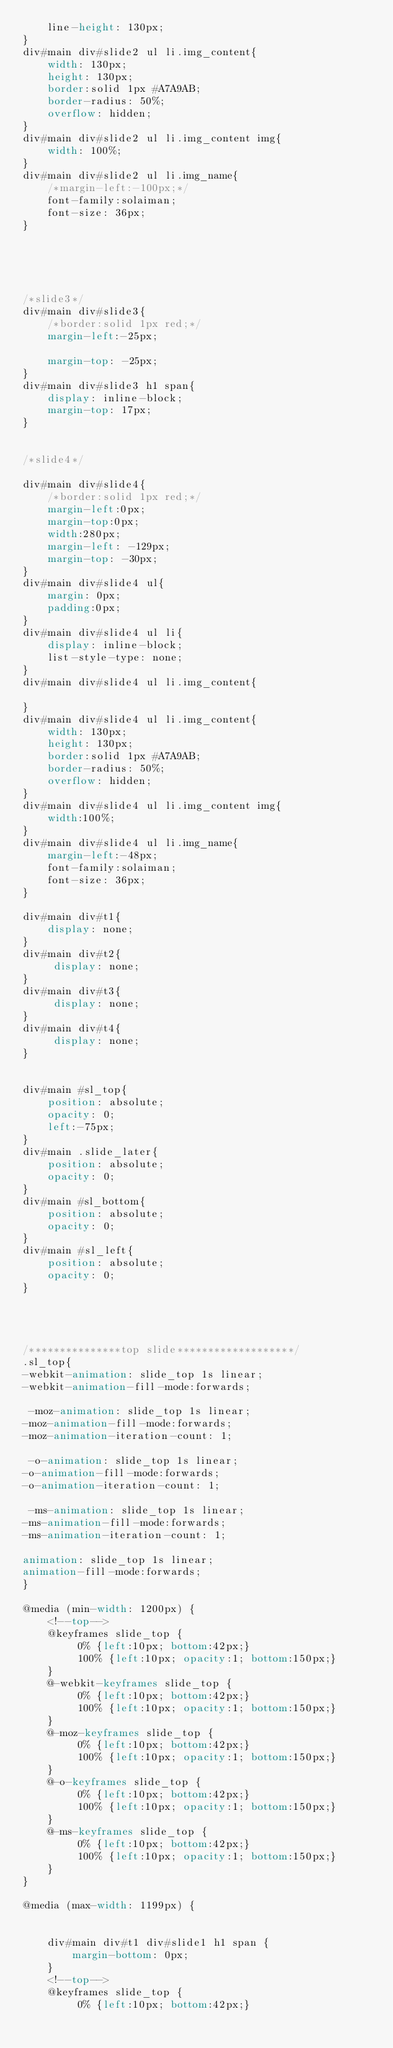Convert code to text. <code><loc_0><loc_0><loc_500><loc_500><_CSS_>    line-height: 130px;
}
div#main div#slide2 ul li.img_content{
    width: 130px;
    height: 130px;
    border:solid 1px #A7A9AB;
    border-radius: 50%;
    overflow: hidden;
}
div#main div#slide2 ul li.img_content img{
    width: 100%;
}
div#main div#slide2 ul li.img_name{
    /*margin-left:-100px;*/
    font-family:solaiman;
    font-size: 36px;
}





/*slide3*/
div#main div#slide3{
    /*border:solid 1px red;*/
    margin-left:-25px;
    
    margin-top: -25px;
}
div#main div#slide3 h1 span{
    display: inline-block;
    margin-top: 17px;
}


/*slide4*/

div#main div#slide4{
    /*border:solid 1px red;*/
    margin-left:0px;
    margin-top:0px;
    width:280px;
    margin-left: -129px;
    margin-top: -30px;
}
div#main div#slide4 ul{
    margin: 0px;
    padding:0px;
}
div#main div#slide4 ul li{
    display: inline-block;
    list-style-type: none;
}
div#main div#slide4 ul li.img_content{

}
div#main div#slide4 ul li.img_content{
    width: 130px;
    height: 130px;
    border:solid 1px #A7A9AB;
    border-radius: 50%;
    overflow: hidden;
}
div#main div#slide4 ul li.img_content img{
    width:100%;
}
div#main div#slide4 ul li.img_name{
    margin-left:-48px;
    font-family:solaiman;
    font-size: 36px;
}

div#main div#t1{
    display: none;
}
div#main div#t2{
     display: none;
}
div#main div#t3{
     display: none;
}
div#main div#t4{
     display: none;
}


div#main #sl_top{
    position: absolute;
    opacity: 0;
    left:-75px;
}
div#main .slide_later{
    position: absolute;
    opacity: 0;
}
div#main #sl_bottom{
    position: absolute;
    opacity: 0;
}
div#main #sl_left{
    position: absolute;
    opacity: 0;
}




/***************top slide*******************/
.sl_top{
-webkit-animation: slide_top 1s linear;
-webkit-animation-fill-mode:forwards;

 -moz-animation: slide_top 1s linear;
-moz-animation-fill-mode:forwards;
-moz-animation-iteration-count: 1;

 -o-animation: slide_top 1s linear;
-o-animation-fill-mode:forwards;
-o-animation-iteration-count: 1;

 -ms-animation: slide_top 1s linear;
-ms-animation-fill-mode:forwards;
-ms-animation-iteration-count: 1;

animation: slide_top 1s linear;
animation-fill-mode:forwards;   
}

@media (min-width: 1200px) {
    <!--top-->
    @keyframes slide_top {
         0% {left:10px; bottom:42px;}
         100% {left:10px; opacity:1; bottom:150px;}
    }
    @-webkit-keyframes slide_top {
         0% {left:10px; bottom:42px;}
         100% {left:10px; opacity:1; bottom:150px;}
    }
    @-moz-keyframes slide_top {
         0% {left:10px; bottom:42px;}
         100% {left:10px; opacity:1; bottom:150px;}
    }
    @-o-keyframes slide_top {
         0% {left:10px; bottom:42px;}
         100% {left:10px; opacity:1; bottom:150px;}
    }
    @-ms-keyframes slide_top {
         0% {left:10px; bottom:42px;}
         100% {left:10px; opacity:1; bottom:150px;}
    }
}

@media (max-width: 1199px) {
    
    
    div#main div#t1 div#slide1 h1 span {
        margin-bottom: 0px;
    }
    <!--top-->
    @keyframes slide_top {
         0% {left:10px; bottom:42px;}</code> 